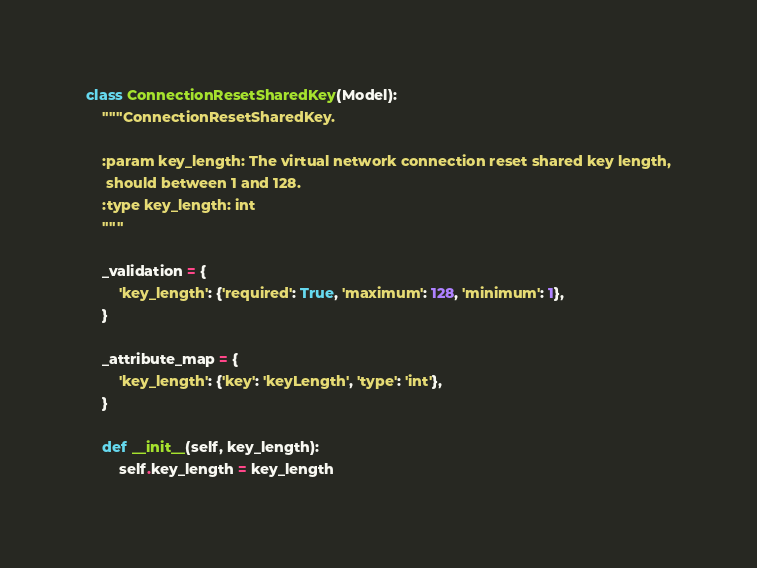<code> <loc_0><loc_0><loc_500><loc_500><_Python_>class ConnectionResetSharedKey(Model):
    """ConnectionResetSharedKey.

    :param key_length: The virtual network connection reset shared key length,
     should between 1 and 128.
    :type key_length: int
    """

    _validation = {
        'key_length': {'required': True, 'maximum': 128, 'minimum': 1},
    }

    _attribute_map = {
        'key_length': {'key': 'keyLength', 'type': 'int'},
    }

    def __init__(self, key_length):
        self.key_length = key_length
</code> 